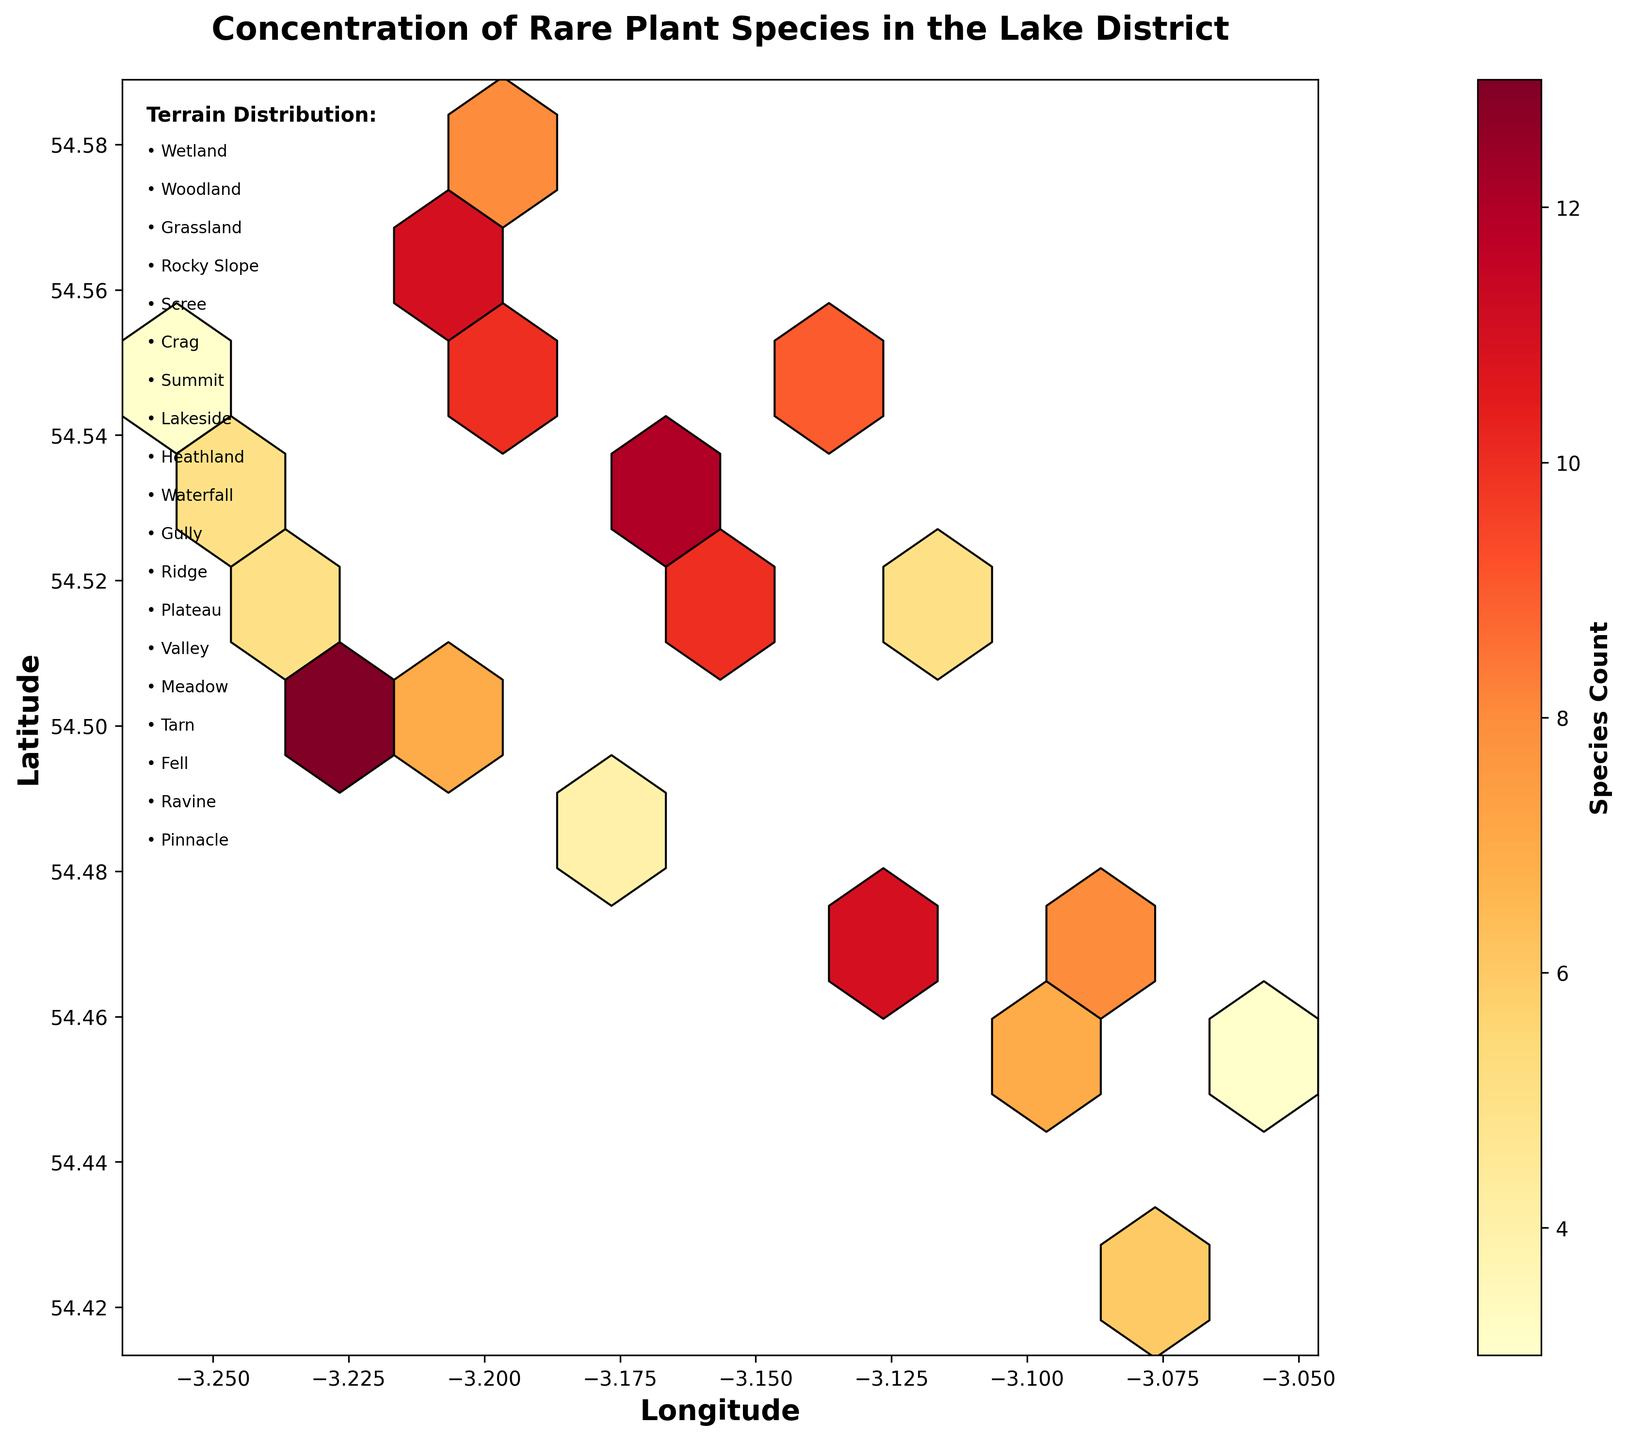What does the title of the plot indicate? The title of the plot provides a clear summary of what the hexbin plot is depicting: "Concentration of Rare Plant Species in the Lake District". This indicates that the plot shows the density or concentration of rare plant species based on their geographic location within the Lake District.
Answer: Concentration of Rare Plant Species in the Lake District What do the colors represent in this hexbin plot? The colors in the hexbin plot represent different concentrations of rare plant species, varying from lighter to darker shades. Here, the color scale transitions from yellow (lower concentration) to deep red (higher concentration), with a color bar indicating the species count.
Answer: Species count Which axis shows the longitude, and what is the range of values? The x-axis shows the longitude. The range of longitude values just slightly varies from the minimum at approximately -3.2567 to the maximum around -3.0564, which are the recorded longitudes of plant data points.
Answer: x-axis; -3.2567 to -3.0564 Which terrain types are listed in the legend on the plot? The legend on the plot lists the types of terrains where the plant species were recorded: Wetland, Woodland, Grassland, Rocky Slope, Scree, Crag, Summit, Lakeside, Heathland, Waterfall, Gully, Ridge, Plateau, Valley, Meadow, Tarn, Fell, and Ravine.
Answer: Wetland, Woodland, Grassland, Rocky Slope, Scree, Crag, Summit, Lakeside, Heathland, Waterfall, Gully, Ridge, Plateau, Valley, Meadow, Tarn, Fell, Ravine Based on the hexbin plot, which region has the highest concentration of rare plant species? To find the region with the highest concentration, look for the darkest shaded hexagons, which represent the highest species counts. These are found in the central region, indicating that the highest concentration of rare plant species is around the latitudes and longitudes where these dark hexagons are located.
Answer: Central region What is the range of species count values depicted in the plot? The species count values range from the minimum indicated by the lightest color in the color bar to the maximum indicated by the darkest color in the color bar. The species count ranges from 3 to 13 across different hexagons in the plot.
Answer: 3 to 13 How many hexagons are used to divide the data points in this hexbin plot? By counting the horizontal and vertical hexagons visible in the plot and considering the grid size of 10 set in the plotting code, there should be around 10 hexagons per axis dividing the data points on the plot. This results in an overall grid.
Answer: Approximately 10 per axis What does the terrain distribution text and the bulleted list provide? The terrain distribution text box provides a summary of the various terrain types within the Lake District in the hexbin plot. These include terrains like Wetland, Woodland, Grassland, and several others, each representing different environmental conditions where plant species data were collected.
Answer: Terrain types Are there more regions with higher species counts at higher or lower altitudes? To determine this, check the species counts (color intensity) corresponding to higher altitudes (greater latitude values) versus lower altitudes (smaller latitude values). Higher concentrations (darker hexagons) appear more frequently at higher altitudes.
Answer: Higher altitudes 